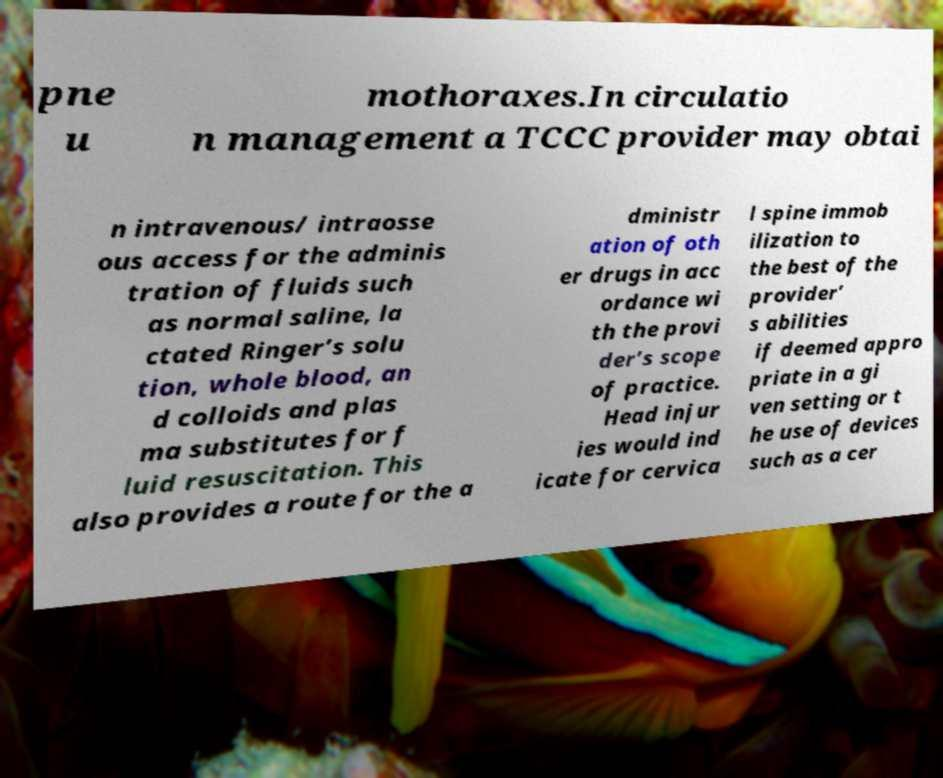Can you accurately transcribe the text from the provided image for me? pne u mothoraxes.In circulatio n management a TCCC provider may obtai n intravenous/ intraosse ous access for the adminis tration of fluids such as normal saline, la ctated Ringer’s solu tion, whole blood, an d colloids and plas ma substitutes for f luid resuscitation. This also provides a route for the a dministr ation of oth er drugs in acc ordance wi th the provi der’s scope of practice. Head injur ies would ind icate for cervica l spine immob ilization to the best of the provider’ s abilities if deemed appro priate in a gi ven setting or t he use of devices such as a cer 